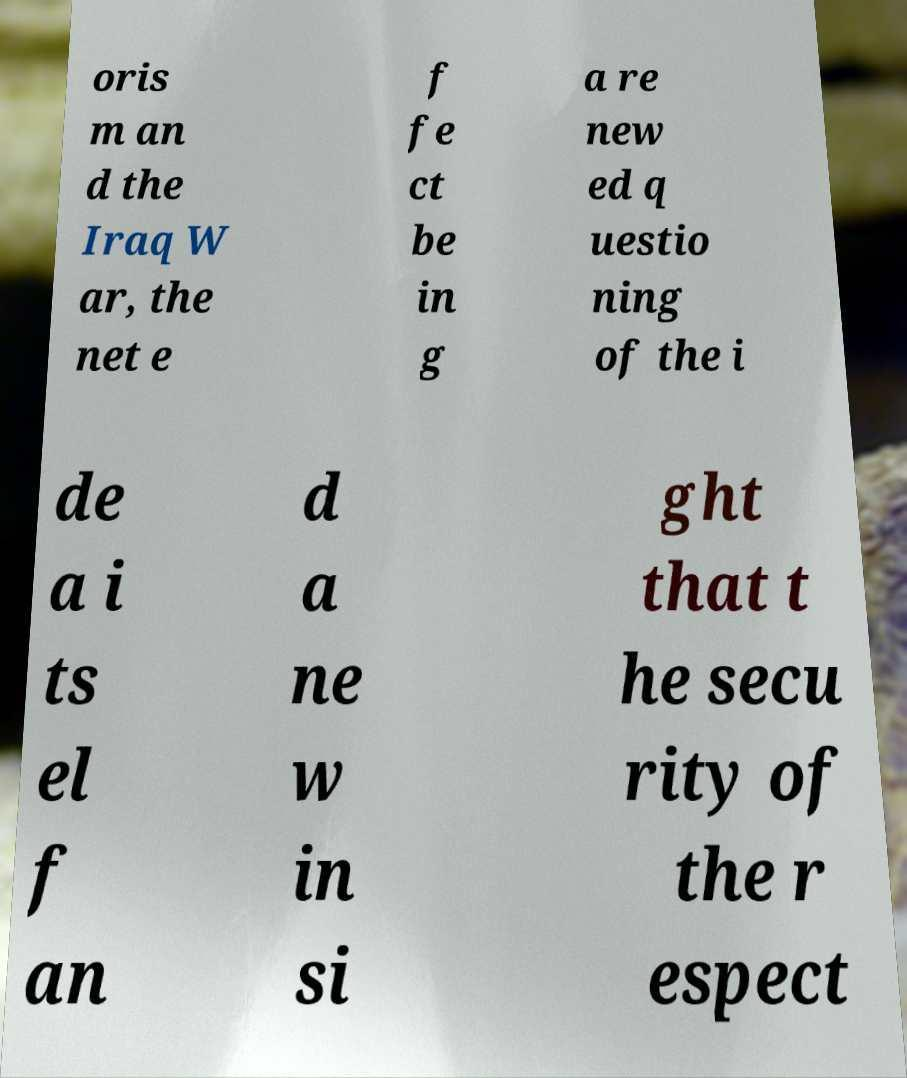Please identify and transcribe the text found in this image. oris m an d the Iraq W ar, the net e f fe ct be in g a re new ed q uestio ning of the i de a i ts el f an d a ne w in si ght that t he secu rity of the r espect 